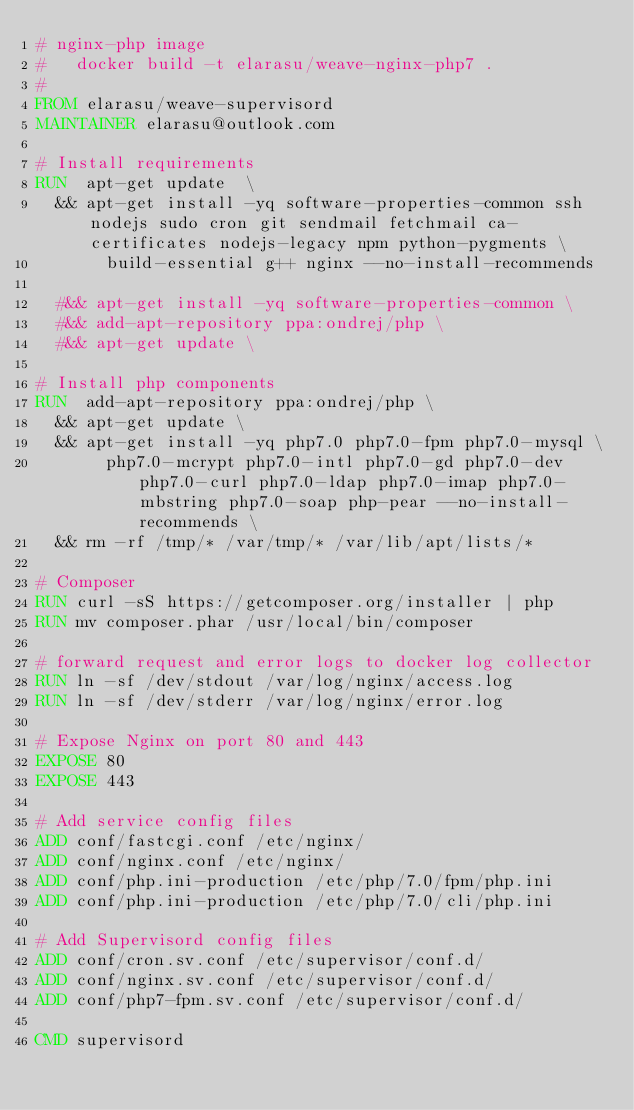<code> <loc_0><loc_0><loc_500><loc_500><_Dockerfile_># nginx-php image 
#   docker build -t elarasu/weave-nginx-php7 .
#
FROM elarasu/weave-supervisord
MAINTAINER elarasu@outlook.com

# Install requirements
RUN  apt-get update  \
  && apt-get install -yq software-properties-common ssh nodejs sudo cron git sendmail fetchmail ca-certificates nodejs-legacy npm python-pygments \
       build-essential g++ nginx --no-install-recommends

  #&& apt-get install -yq software-properties-common \
  #&& add-apt-repository ppa:ondrej/php \
  #&& apt-get update \

# Install php components
RUN  add-apt-repository ppa:ondrej/php \
  && apt-get update \
  && apt-get install -yq php7.0 php7.0-fpm php7.0-mysql \
       php7.0-mcrypt php7.0-intl php7.0-gd php7.0-dev php7.0-curl php7.0-ldap php7.0-imap php7.0-mbstring php7.0-soap php-pear --no-install-recommends \
  && rm -rf /tmp/* /var/tmp/* /var/lib/apt/lists/*

# Composer
RUN curl -sS https://getcomposer.org/installer | php
RUN mv composer.phar /usr/local/bin/composer

# forward request and error logs to docker log collector
RUN ln -sf /dev/stdout /var/log/nginx/access.log
RUN ln -sf /dev/stderr /var/log/nginx/error.log

# Expose Nginx on port 80 and 443
EXPOSE 80
EXPOSE 443

# Add service config files
ADD conf/fastcgi.conf /etc/nginx/
ADD conf/nginx.conf /etc/nginx/
ADD conf/php.ini-production /etc/php/7.0/fpm/php.ini
ADD conf/php.ini-production /etc/php/7.0/cli/php.ini

# Add Supervisord config files
ADD conf/cron.sv.conf /etc/supervisor/conf.d/
ADD conf/nginx.sv.conf /etc/supervisor/conf.d/
ADD conf/php7-fpm.sv.conf /etc/supervisor/conf.d/

CMD supervisord

</code> 